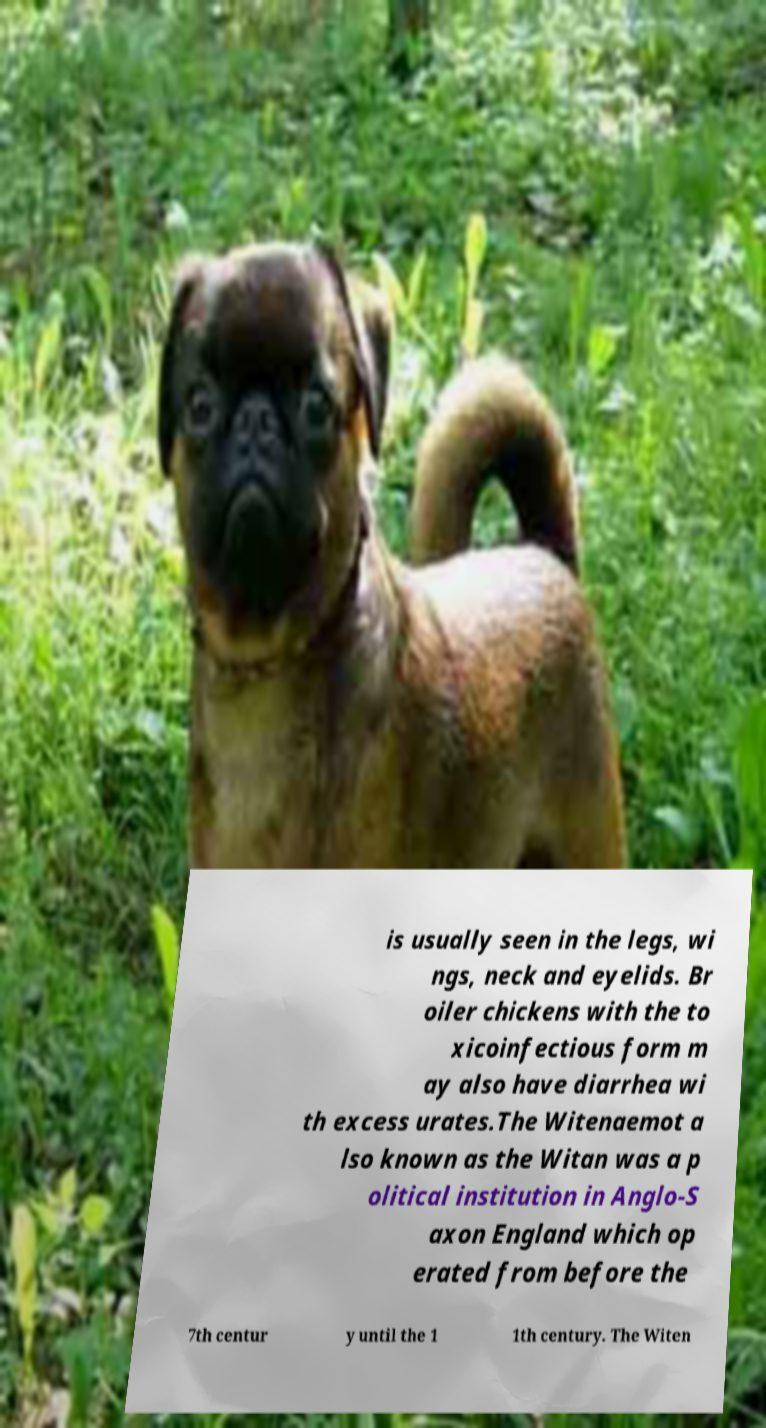For documentation purposes, I need the text within this image transcribed. Could you provide that? is usually seen in the legs, wi ngs, neck and eyelids. Br oiler chickens with the to xicoinfectious form m ay also have diarrhea wi th excess urates.The Witenaemot a lso known as the Witan was a p olitical institution in Anglo-S axon England which op erated from before the 7th centur y until the 1 1th century. The Witen 